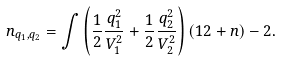Convert formula to latex. <formula><loc_0><loc_0><loc_500><loc_500>n _ { q _ { 1 } , q _ { 2 } } = \int \left ( \frac { 1 } { 2 } \frac { q _ { 1 } ^ { 2 } } { V _ { 1 } ^ { 2 } } + \frac { 1 } { 2 } \frac { q _ { 2 } ^ { 2 } } { V _ { 2 } ^ { 2 } } \right ) ( 1 2 + n ) - 2 .</formula> 